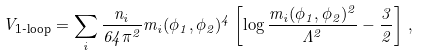<formula> <loc_0><loc_0><loc_500><loc_500>V _ { \text {1-loop} } = \sum _ { i } \frac { n _ { i } } { 6 4 \pi ^ { 2 } } m _ { i } ( \phi _ { 1 } , \phi _ { 2 } ) ^ { 4 } \left [ \log \frac { m _ { i } ( \phi _ { 1 } , \phi _ { 2 } ) ^ { 2 } } { \Lambda ^ { 2 } } - \frac { 3 } { 2 } \right ] \, ,</formula> 